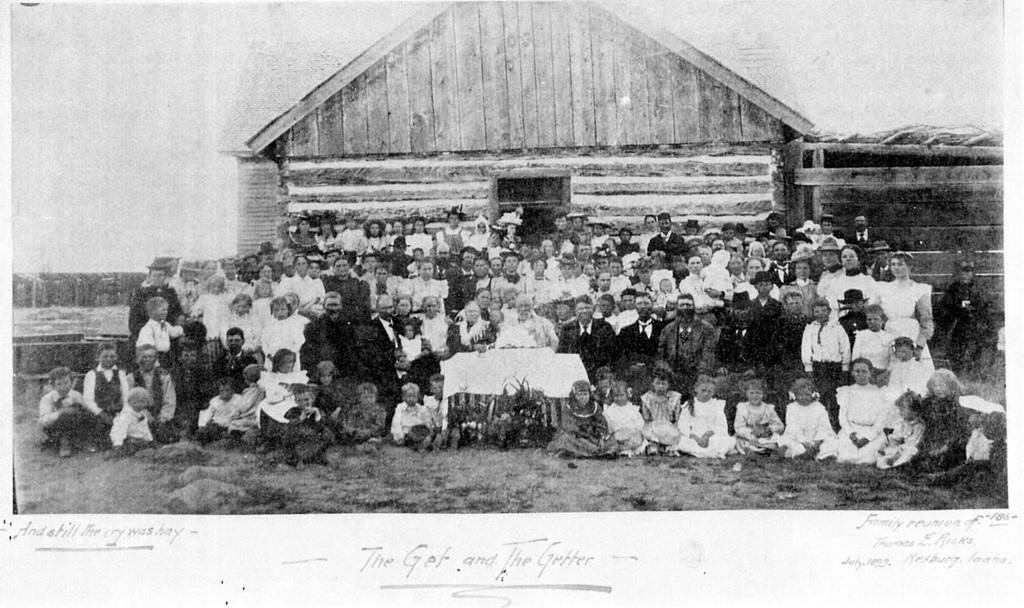What is the color scheme of the image? The image is black and white. Who or what can be seen in the image? There is a group of people in the image. What object is present in the image that might be used for eating or working? There is a table in the image. What type of structure is visible in the image? There is a house with a roof in the image. What part of the natural environment is visible in the image? The sky is visible in the image. What is written or displayed at the bottom of the image? There is text at the bottom of the image. What type of substance is being cooked in the oven in the image? There is no oven present in the image, so it is not possible to determine what, if any, substance might be cooking. 